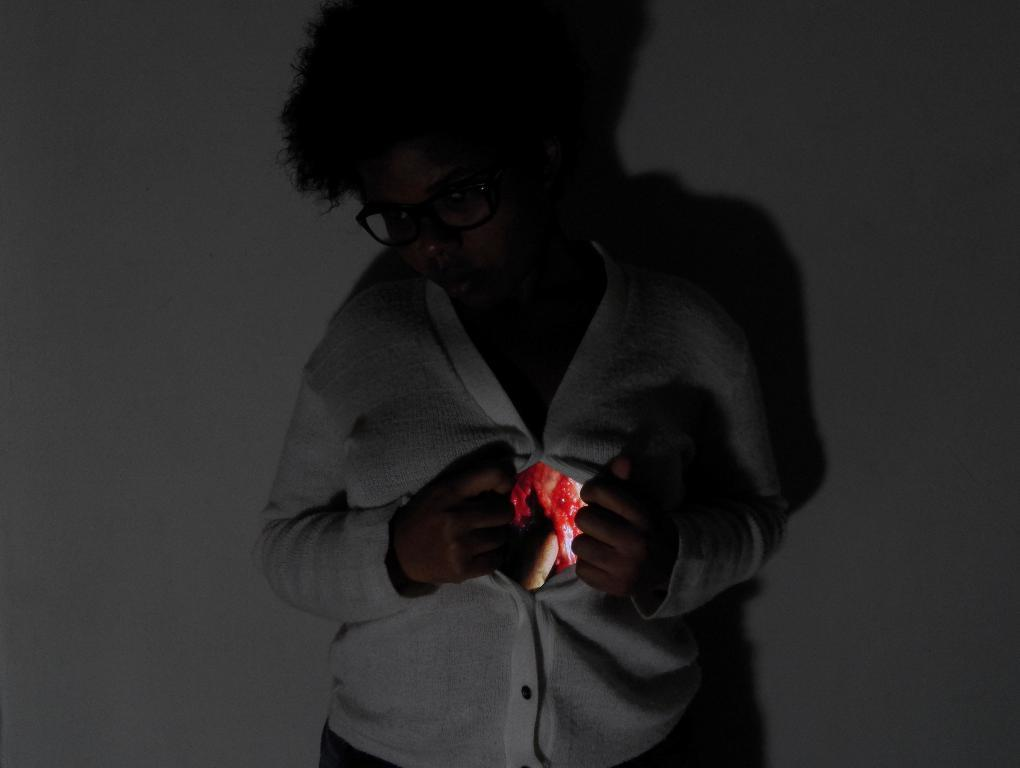Who is the main subject in the image? There is a woman in the center of the image. What can be seen in the background of the image? There is a wall in the background of the image. What type of caption is written on the wall in the image? There is no caption written on the wall in the image. What fictional character is depicted in the image? The image does not depict any fictional characters; it features a woman. 